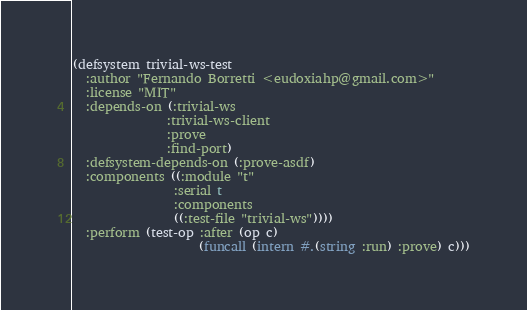<code> <loc_0><loc_0><loc_500><loc_500><_Lisp_>(defsystem trivial-ws-test
  :author "Fernando Borretti <eudoxiahp@gmail.com>"
  :license "MIT"
  :depends-on (:trivial-ws
               :trivial-ws-client
               :prove
               :find-port)
  :defsystem-depends-on (:prove-asdf)
  :components ((:module "t"
                :serial t
                :components
                ((:test-file "trivial-ws"))))
  :perform (test-op :after (op c)
                    (funcall (intern #.(string :run) :prove) c)))
</code> 